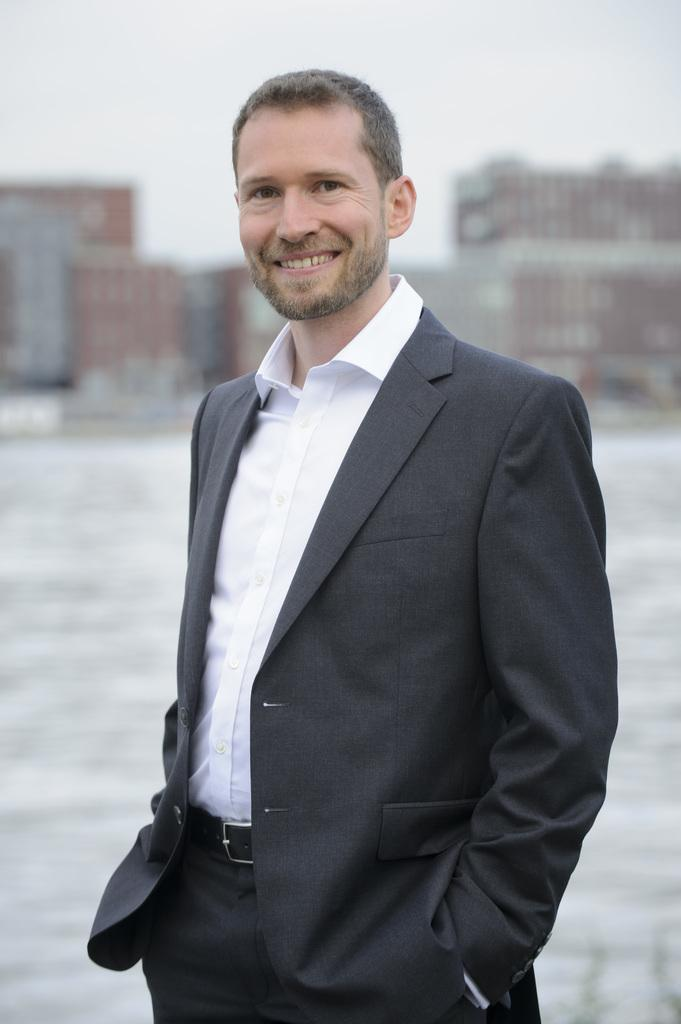Who is present in the image? There is a man in the image. What is the man wearing? The man is wearing a black suit and a white shirt. What is the man doing in the image? The man is standing. What can be seen in the background of the image? There is a building in the background of the image. What is visible above the building in the image? The sky is visible above the building. What historical event is being commemorated by the man in the image? There is no indication of a historical event being commemorated in the image; the man is simply standing and wearing a black suit and a white shirt. 